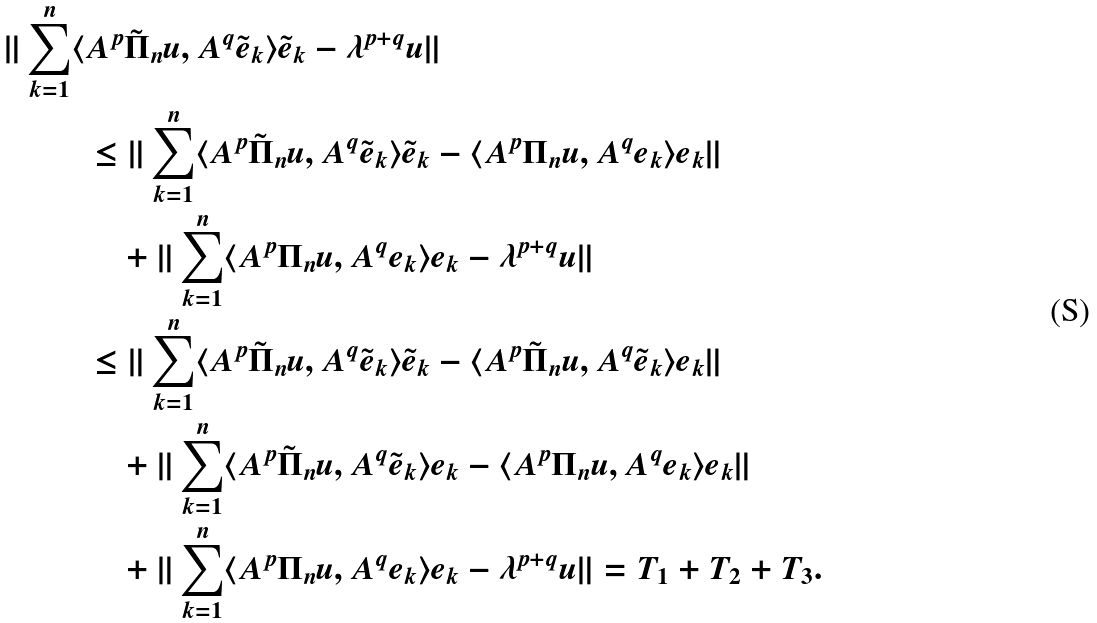<formula> <loc_0><loc_0><loc_500><loc_500>\| \sum _ { k = 1 } ^ { n } \langle & A ^ { p } \tilde { \Pi } _ { n } u , A ^ { q } \tilde { e } _ { k } \rangle \tilde { e } _ { k } - \lambda ^ { p + q } u \| \\ & \leq \| \sum _ { k = 1 } ^ { n } \langle A ^ { p } \tilde { \Pi } _ { n } u , A ^ { q } \tilde { e } _ { k } \rangle \tilde { e } _ { k } - \langle A ^ { p } \Pi _ { n } u , A ^ { q } e _ { k } \rangle e _ { k } \| \\ & \quad + \| \sum _ { k = 1 } ^ { n } \langle A ^ { p } \Pi _ { n } u , A ^ { q } e _ { k } \rangle e _ { k } - \lambda ^ { p + q } u \| \\ & \leq \| \sum _ { k = 1 } ^ { n } \langle A ^ { p } \tilde { \Pi } _ { n } u , A ^ { q } \tilde { e } _ { k } \rangle \tilde { e } _ { k } - \langle A ^ { p } \tilde { \Pi } _ { n } u , A ^ { q } \tilde { e } _ { k } \rangle e _ { k } \| \\ & \quad + \| \sum _ { k = 1 } ^ { n } \langle A ^ { p } \tilde { \Pi } _ { n } u , A ^ { q } \tilde { e } _ { k } \rangle e _ { k } - \langle A ^ { p } \Pi _ { n } u , A ^ { q } e _ { k } \rangle e _ { k } \| \\ & \quad + \| \sum _ { k = 1 } ^ { n } \langle A ^ { p } \Pi _ { n } u , A ^ { q } e _ { k } \rangle e _ { k } - \lambda ^ { p + q } u \| = T _ { 1 } + T _ { 2 } + T _ { 3 } .</formula> 